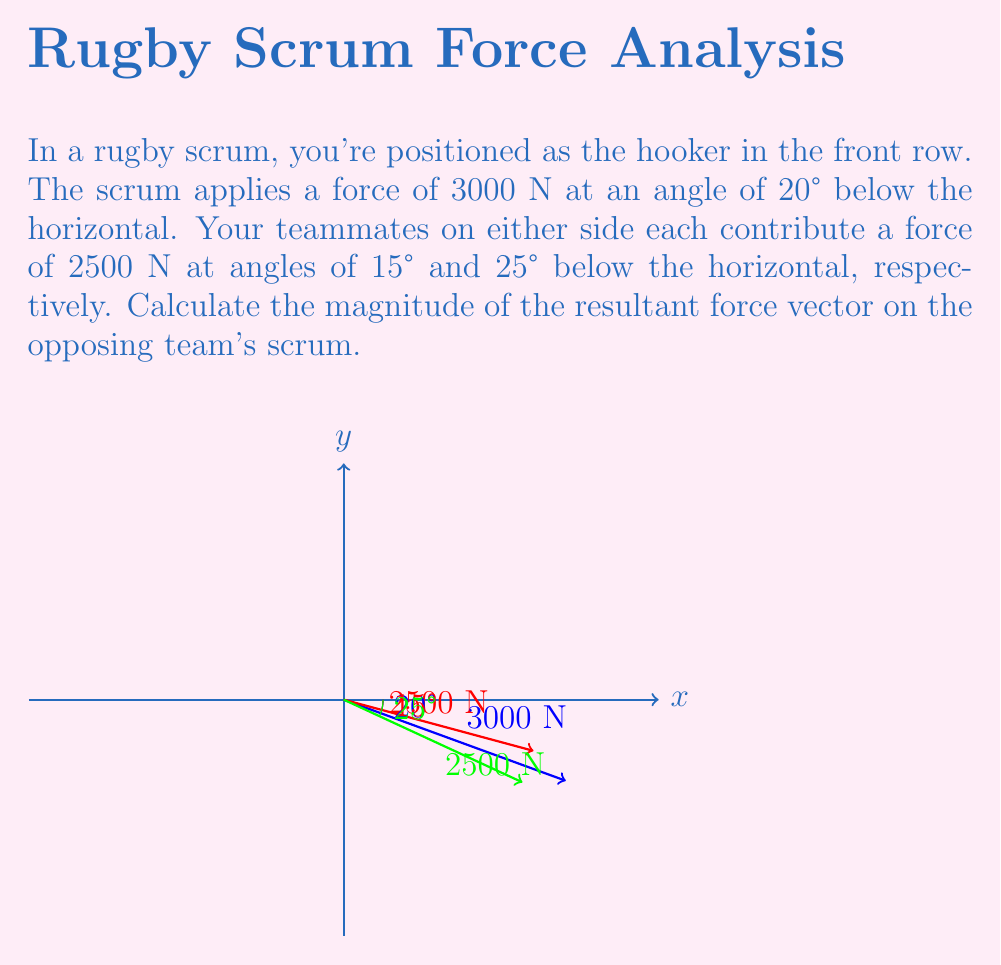Give your solution to this math problem. Let's approach this step-by-step:

1) First, we need to break down each force into its x and y components using trigonometry.

   For the 3000 N force:
   $F_{x1} = 3000 \cos(20°) = 2819.08$ N
   $F_{y1} = -3000 \sin(20°) = -1025.52$ N

   For the first 2500 N force:
   $F_{x2} = 2500 \cos(15°) = 2415.06$ N
   $F_{y2} = -2500 \sin(15°) = -646.95$ N

   For the second 2500 N force:
   $F_{x3} = 2500 \cos(25°) = 2265.43$ N
   $F_{y3} = -2500 \sin(25°) = -1056.47$ N

2) Now, we sum up all the x components and all the y components:

   $F_x = F_{x1} + F_{x2} + F_{x3} = 2819.08 + 2415.06 + 2265.43 = 7499.57$ N
   $F_y = F_{y1} + F_{y2} + F_{y3} = -1025.52 - 646.95 - 1056.47 = -2728.94$ N

3) The resultant force vector is $(F_x, F_y) = (7499.57, -2728.94)$

4) To find the magnitude of this vector, we use the Pythagorean theorem:

   $|F| = \sqrt{F_x^2 + F_y^2} = \sqrt{7499.57^2 + (-2728.94)^2} = 7981.46$ N

Therefore, the magnitude of the resultant force vector is approximately 7981.46 N.
Answer: 7981.46 N 